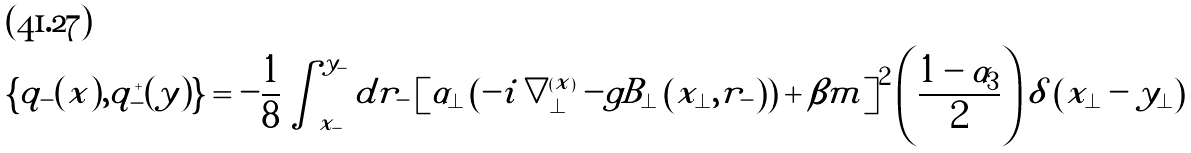<formula> <loc_0><loc_0><loc_500><loc_500>\left \{ q _ { - } ( x ) , q _ { - } ^ { + } ( y ) \right \} = - \frac { 1 } { 8 } \int ^ { y _ { - } } _ { x _ { - } } d r _ { - } \left [ \alpha _ { \perp } \left ( - i \bigtriangledown _ { \perp } ^ { ( x ) } - g B _ { \perp } \left ( x _ { \perp } , r _ { - } \right ) \right ) + \beta m \right ] ^ { 2 } \left ( \frac { 1 - \alpha _ { 3 } } { 2 } \right ) \delta \left ( x _ { \perp } - y _ { \perp } \right )</formula> 